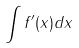<formula> <loc_0><loc_0><loc_500><loc_500>\int f ^ { \prime } ( x ) d x</formula> 